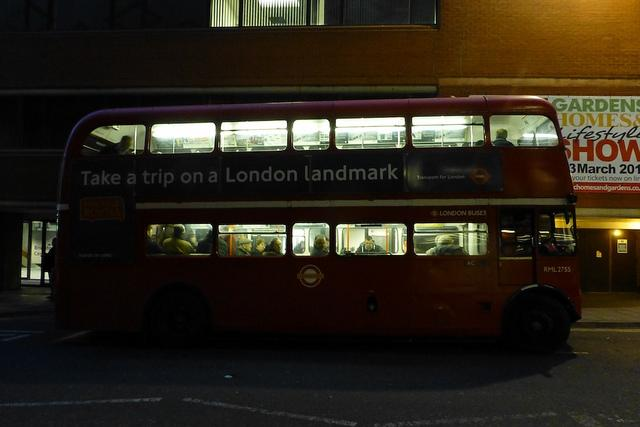Why is the light on inside the double-decker bus? waiting 